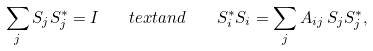Convert formula to latex. <formula><loc_0><loc_0><loc_500><loc_500>\sum _ { j } S _ { j } S _ { j } ^ { * } = I \quad t e x t { a n d } \quad S _ { i } ^ { * } S _ { i } = \sum _ { j } A _ { i j } \, S _ { j } S _ { j } ^ { * } ,</formula> 